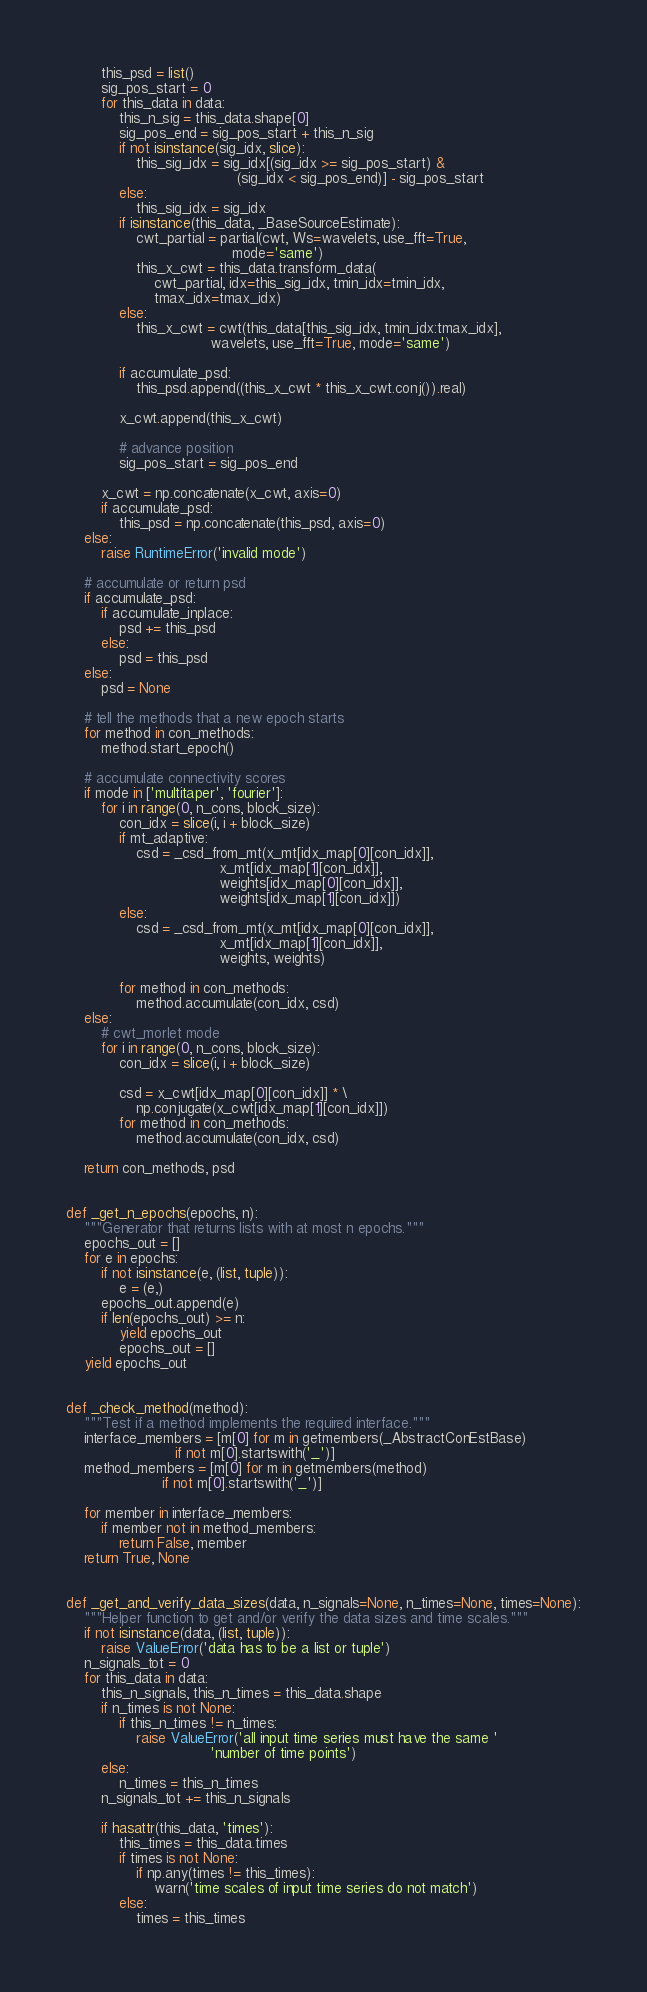<code> <loc_0><loc_0><loc_500><loc_500><_Python_>        this_psd = list()
        sig_pos_start = 0
        for this_data in data:
            this_n_sig = this_data.shape[0]
            sig_pos_end = sig_pos_start + this_n_sig
            if not isinstance(sig_idx, slice):
                this_sig_idx = sig_idx[(sig_idx >= sig_pos_start) &
                                       (sig_idx < sig_pos_end)] - sig_pos_start
            else:
                this_sig_idx = sig_idx
            if isinstance(this_data, _BaseSourceEstimate):
                cwt_partial = partial(cwt, Ws=wavelets, use_fft=True,
                                      mode='same')
                this_x_cwt = this_data.transform_data(
                    cwt_partial, idx=this_sig_idx, tmin_idx=tmin_idx,
                    tmax_idx=tmax_idx)
            else:
                this_x_cwt = cwt(this_data[this_sig_idx, tmin_idx:tmax_idx],
                                 wavelets, use_fft=True, mode='same')

            if accumulate_psd:
                this_psd.append((this_x_cwt * this_x_cwt.conj()).real)

            x_cwt.append(this_x_cwt)

            # advance position
            sig_pos_start = sig_pos_end

        x_cwt = np.concatenate(x_cwt, axis=0)
        if accumulate_psd:
            this_psd = np.concatenate(this_psd, axis=0)
    else:
        raise RuntimeError('invalid mode')

    # accumulate or return psd
    if accumulate_psd:
        if accumulate_inplace:
            psd += this_psd
        else:
            psd = this_psd
    else:
        psd = None

    # tell the methods that a new epoch starts
    for method in con_methods:
        method.start_epoch()

    # accumulate connectivity scores
    if mode in ['multitaper', 'fourier']:
        for i in range(0, n_cons, block_size):
            con_idx = slice(i, i + block_size)
            if mt_adaptive:
                csd = _csd_from_mt(x_mt[idx_map[0][con_idx]],
                                   x_mt[idx_map[1][con_idx]],
                                   weights[idx_map[0][con_idx]],
                                   weights[idx_map[1][con_idx]])
            else:
                csd = _csd_from_mt(x_mt[idx_map[0][con_idx]],
                                   x_mt[idx_map[1][con_idx]],
                                   weights, weights)

            for method in con_methods:
                method.accumulate(con_idx, csd)
    else:
        # cwt_morlet mode
        for i in range(0, n_cons, block_size):
            con_idx = slice(i, i + block_size)

            csd = x_cwt[idx_map[0][con_idx]] * \
                np.conjugate(x_cwt[idx_map[1][con_idx]])
            for method in con_methods:
                method.accumulate(con_idx, csd)

    return con_methods, psd


def _get_n_epochs(epochs, n):
    """Generator that returns lists with at most n epochs."""
    epochs_out = []
    for e in epochs:
        if not isinstance(e, (list, tuple)):
            e = (e,)
        epochs_out.append(e)
        if len(epochs_out) >= n:
            yield epochs_out
            epochs_out = []
    yield epochs_out


def _check_method(method):
    """Test if a method implements the required interface."""
    interface_members = [m[0] for m in getmembers(_AbstractConEstBase)
                         if not m[0].startswith('_')]
    method_members = [m[0] for m in getmembers(method)
                      if not m[0].startswith('_')]

    for member in interface_members:
        if member not in method_members:
            return False, member
    return True, None


def _get_and_verify_data_sizes(data, n_signals=None, n_times=None, times=None):
    """Helper function to get and/or verify the data sizes and time scales."""
    if not isinstance(data, (list, tuple)):
        raise ValueError('data has to be a list or tuple')
    n_signals_tot = 0
    for this_data in data:
        this_n_signals, this_n_times = this_data.shape
        if n_times is not None:
            if this_n_times != n_times:
                raise ValueError('all input time series must have the same '
                                 'number of time points')
        else:
            n_times = this_n_times
        n_signals_tot += this_n_signals

        if hasattr(this_data, 'times'):
            this_times = this_data.times
            if times is not None:
                if np.any(times != this_times):
                    warn('time scales of input time series do not match')
            else:
                times = this_times
</code> 